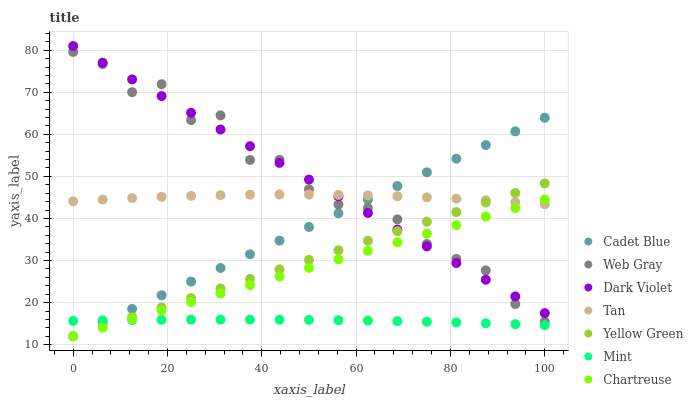Does Mint have the minimum area under the curve?
Answer yes or no. Yes. Does Dark Violet have the maximum area under the curve?
Answer yes or no. Yes. Does Yellow Green have the minimum area under the curve?
Answer yes or no. No. Does Yellow Green have the maximum area under the curve?
Answer yes or no. No. Is Cadet Blue the smoothest?
Answer yes or no. Yes. Is Web Gray the roughest?
Answer yes or no. Yes. Is Yellow Green the smoothest?
Answer yes or no. No. Is Yellow Green the roughest?
Answer yes or no. No. Does Cadet Blue have the lowest value?
Answer yes or no. Yes. Does Dark Violet have the lowest value?
Answer yes or no. No. Does Dark Violet have the highest value?
Answer yes or no. Yes. Does Yellow Green have the highest value?
Answer yes or no. No. Is Mint less than Web Gray?
Answer yes or no. Yes. Is Tan greater than Mint?
Answer yes or no. Yes. Does Cadet Blue intersect Dark Violet?
Answer yes or no. Yes. Is Cadet Blue less than Dark Violet?
Answer yes or no. No. Is Cadet Blue greater than Dark Violet?
Answer yes or no. No. Does Mint intersect Web Gray?
Answer yes or no. No. 